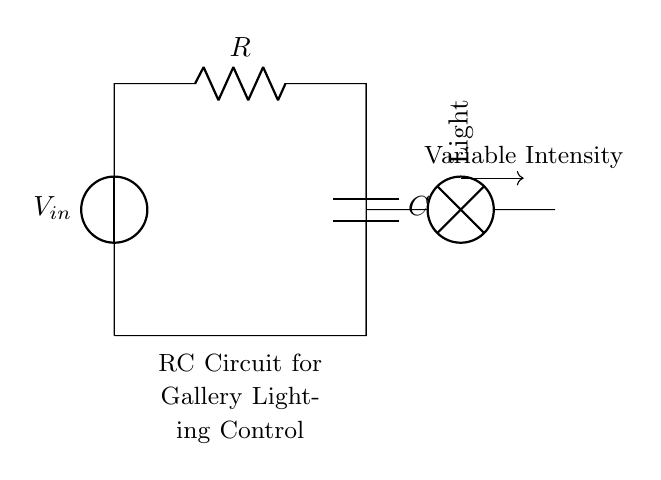What is the input voltage in this circuit? The input voltage is labeled as V_in, directly indicating where the voltage is applied in the circuit. It is the source voltage that initiates the current flow.
Answer: V_in What components are present in the circuit? The circuit contains a voltage source, a resistor, a capacitor, and a light (lamp). Each component has a specific function: the resistor limits current, the capacitor stores charge, and the lamp represents the load.
Answer: Voltage source, resistor, capacitor, light What is the purpose of the resistor in this circuit? The resistor's purpose is to limit current flowing through the circuit. This regulation helps to protect the other components and control the light intensity by varying the resistance.
Answer: Limit current What is the function of the capacitor? The capacitor stores electrical energy when charged and releases it when needed. This ability smoothens the intensity of the light by allowing for gradual changes when the circuit is switched on or off.
Answer: Store energy How does changing the resistance affect the light intensity? Changing the resistance alters the amount of current flowing through the circuit. A higher resistance decreases current flow, thereby dimming the light, while a lower resistance increases current flow, brightening the light.
Answer: Affects current and light intensity What is the relationship between the resistor and capacitor in this circuit regarding time response? The resistor and capacitor together form an RC time constant, which dictates how quickly the circuit responds to changes in voltage. The time constant (tau) is calculated as R multiplied by C, affecting how fast the light intensity adjusts.
Answer: Create time constant 